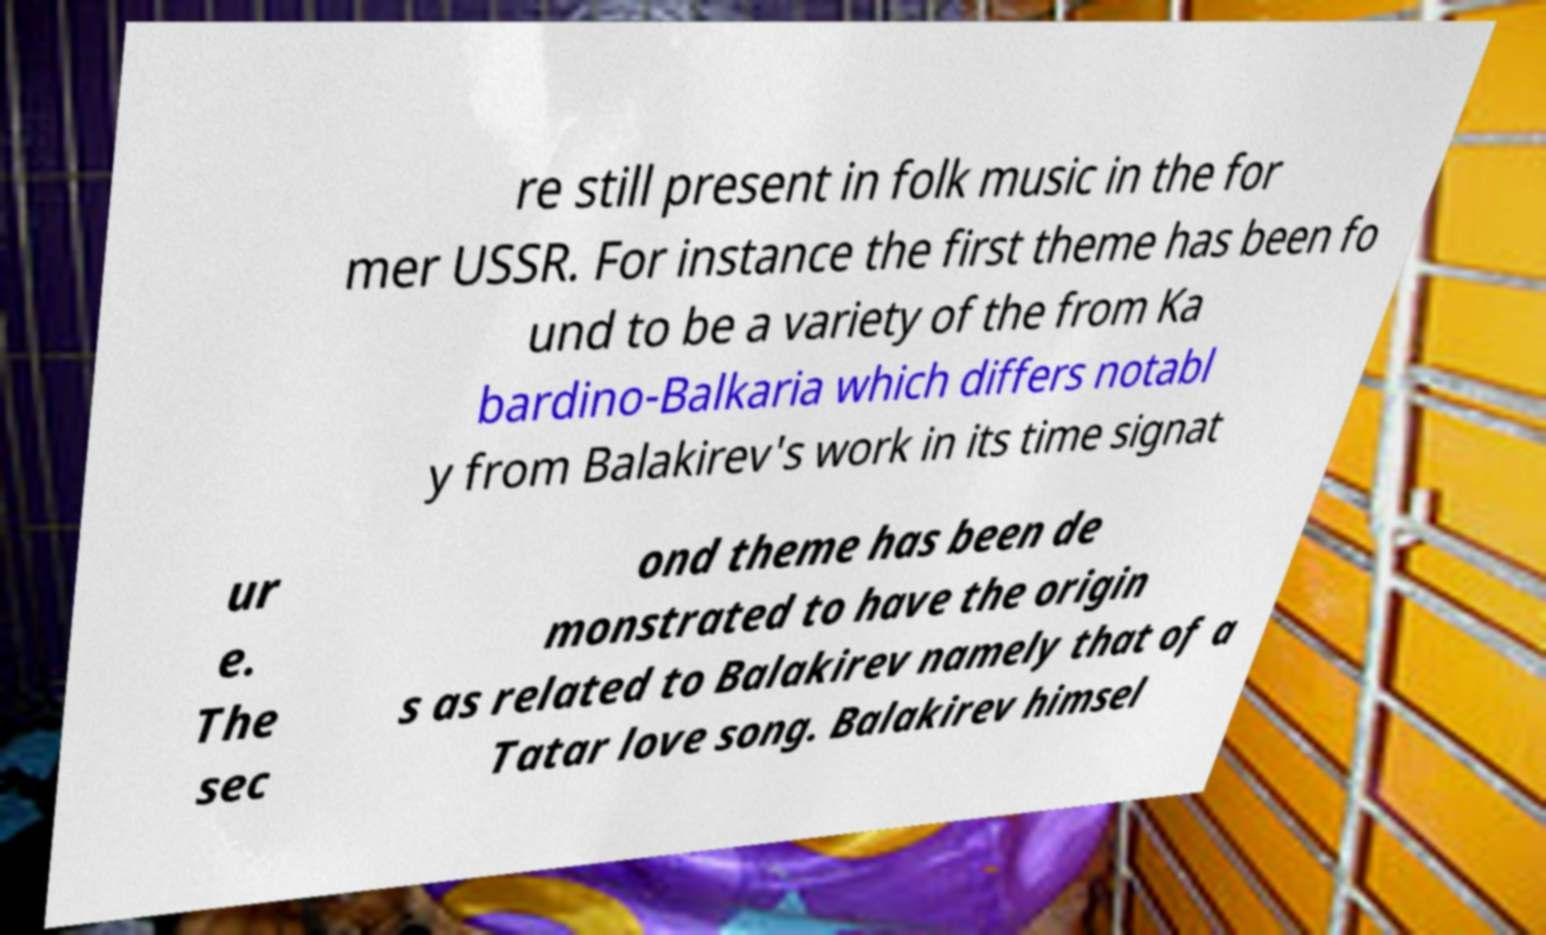Please identify and transcribe the text found in this image. re still present in folk music in the for mer USSR. For instance the first theme has been fo und to be a variety of the from Ka bardino-Balkaria which differs notabl y from Balakirev's work in its time signat ur e. The sec ond theme has been de monstrated to have the origin s as related to Balakirev namely that of a Tatar love song. Balakirev himsel 